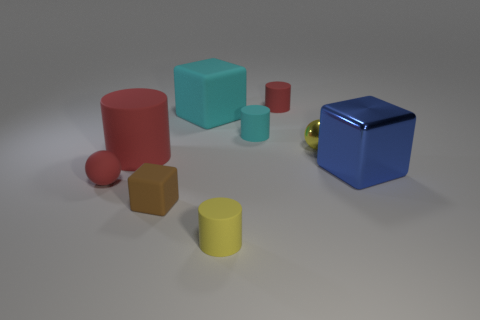Subtract all tiny rubber cylinders. How many cylinders are left? 1 Subtract all blue spheres. How many red cylinders are left? 2 Add 1 big cyan cylinders. How many objects exist? 10 Subtract all yellow spheres. How many spheres are left? 1 Subtract all balls. How many objects are left? 7 Subtract 0 green cylinders. How many objects are left? 9 Subtract 2 blocks. How many blocks are left? 1 Subtract all gray spheres. Subtract all yellow cylinders. How many spheres are left? 2 Subtract all large red objects. Subtract all big blue metal things. How many objects are left? 7 Add 5 big blue metallic objects. How many big blue metallic objects are left? 6 